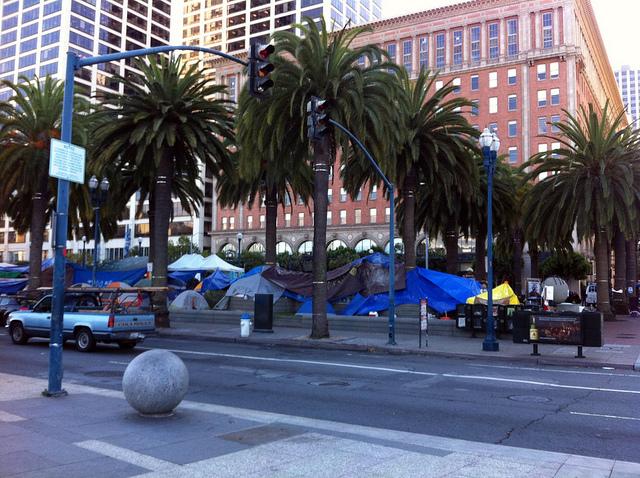What color are the leaves on the trees?
Answer briefly. Green. What color are the umbrellas?
Concise answer only. Blue. Is this a tropical scene?
Write a very short answer. No. 